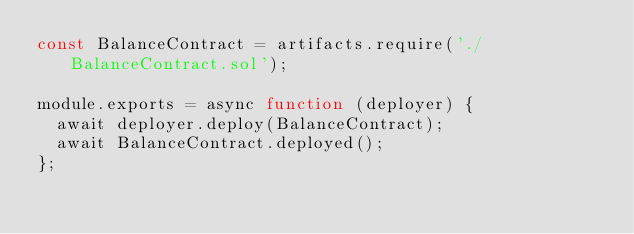<code> <loc_0><loc_0><loc_500><loc_500><_JavaScript_>const BalanceContract = artifacts.require('./BalanceContract.sol');

module.exports = async function (deployer) {
  await deployer.deploy(BalanceContract);
  await BalanceContract.deployed();
};
</code> 